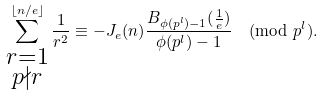<formula> <loc_0><loc_0><loc_500><loc_500>\sum ^ { \lfloor n / e \rfloor } _ { \substack { r = 1 \\ p \nmid r } } \frac { 1 } { r ^ { 2 } } \equiv - J _ { e } ( n ) \frac { B _ { \phi ( p ^ { l } ) - 1 } ( \frac { 1 } { e } ) } { \phi ( p ^ { l } ) - 1 } \pmod { p ^ { l } } .</formula> 